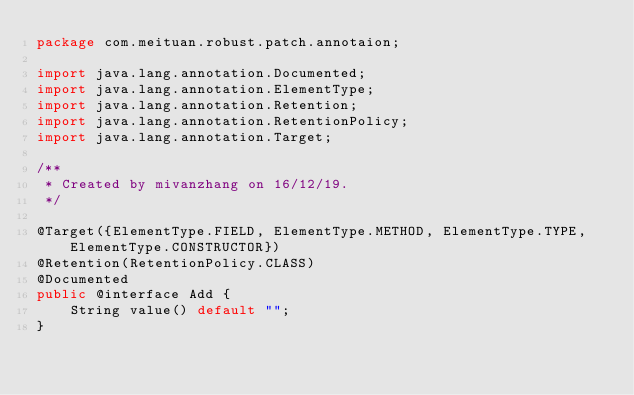<code> <loc_0><loc_0><loc_500><loc_500><_Java_>package com.meituan.robust.patch.annotaion;

import java.lang.annotation.Documented;
import java.lang.annotation.ElementType;
import java.lang.annotation.Retention;
import java.lang.annotation.RetentionPolicy;
import java.lang.annotation.Target;

/**
 * Created by mivanzhang on 16/12/19.
 */

@Target({ElementType.FIELD, ElementType.METHOD, ElementType.TYPE, ElementType.CONSTRUCTOR})
@Retention(RetentionPolicy.CLASS)
@Documented
public @interface Add {
    String value() default "";
}</code> 